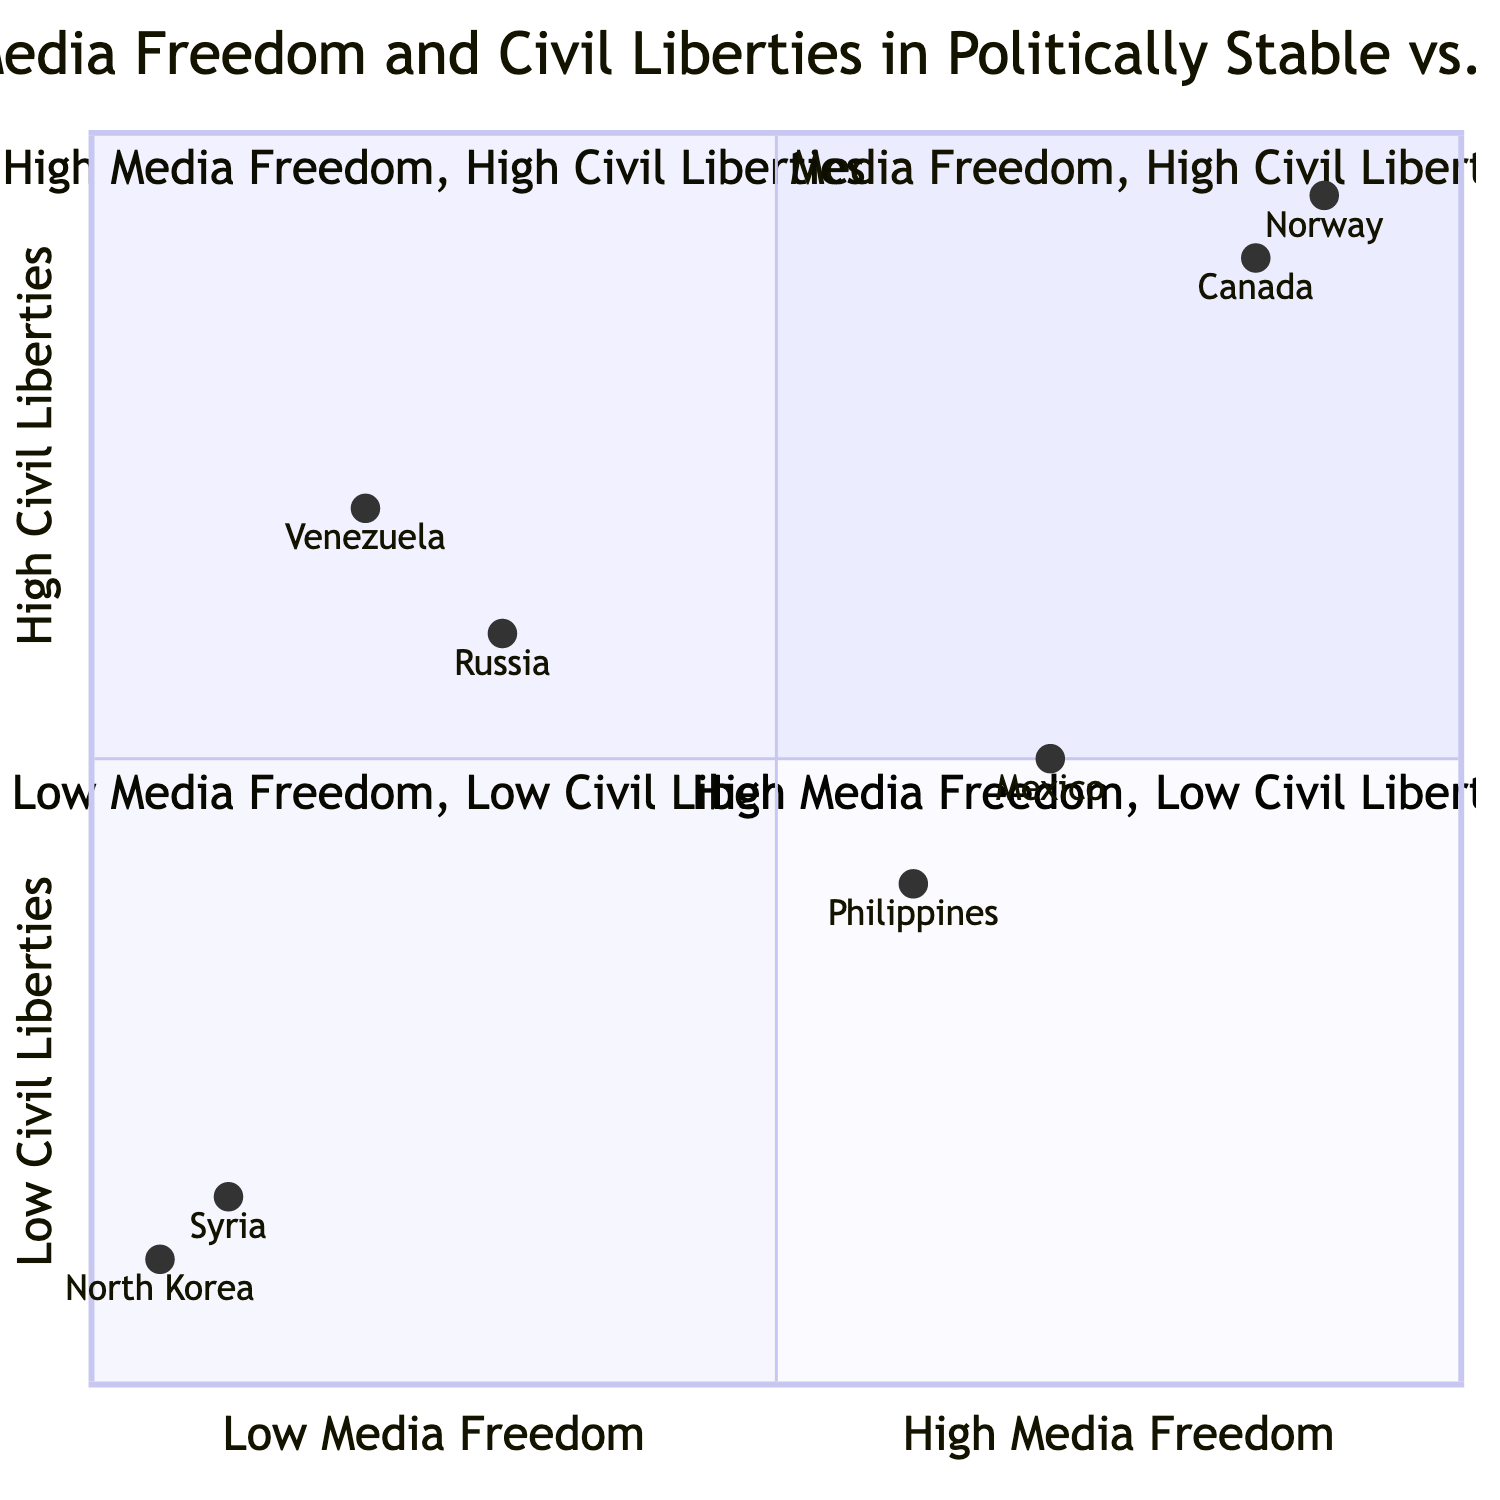What countries are in Quadrant 1? Quadrant 1 is labeled as "Low Media Freedom, High Civil Liberties." The examples provided in this quadrant are Venezuela and Russia.
Answer: Venezuela, Russia How many countries are in Quadrant 3? Quadrant 3 is labeled as "Low Media Freedom, Low Civil Liberties," which includes two countries: North Korea and Syria. This counts the total.
Answer: 2 Which country has the highest civil liberties? Looking at the y-axis (Civil Liberties), Norway has the highest value at 0.95, making it the country with the highest civil liberties among those listed.
Answer: Norway What is the media freedom value of Canada? Canada is positioned at [0.85, 0.9] on the chart, indicating a media freedom value of 0.85. The first number represents the media freedom on the x-axis.
Answer: 0.85 Are there any countries with high media freedom but low civil liberties? Quadrant 4 is labeled "High Media Freedom, Low Civil Liberties," which includes the countries Philippines and Mexico, indicating that such countries do exist.
Answer: Yes Which quadrant contains countries with both high civil liberties and high media freedom? Quadrant 2 is labeled "High Media Freedom, High Civil Liberties," which contains the countries Norway and Canada.
Answer: Quadrant 2 List the examples of countries in Quadrant 4. Quadrant 4 is labeled "High Media Freedom, Low Civil Liberties," and the countries listed in this quadrant are the Philippines and Mexico.
Answer: Philippines, Mexico Which country has both low media freedom and low civil liberties? Both North Korea and Syria are examples of countries that fall into the "Low Media Freedom, Low Civil Liberties" category as per Quadrant 3.
Answer: North Korea, Syria How does media freedom correlate with civil liberties in the chart? The chart shows that countries with high media freedom (Q2 and Q4) tend to have either high or low civil liberties, but low media freedom (Q1 and Q3) results in low civil liberties. This indicates a complex relationship.
Answer: Complex relationship 